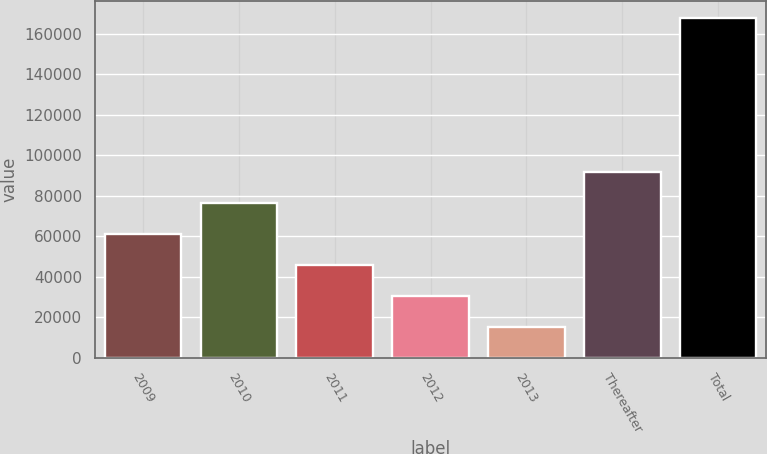Convert chart. <chart><loc_0><loc_0><loc_500><loc_500><bar_chart><fcel>2009<fcel>2010<fcel>2011<fcel>2012<fcel>2013<fcel>Thereafter<fcel>Total<nl><fcel>61017.6<fcel>76275.8<fcel>45759.4<fcel>30501.2<fcel>15243<fcel>91534<fcel>167825<nl></chart> 